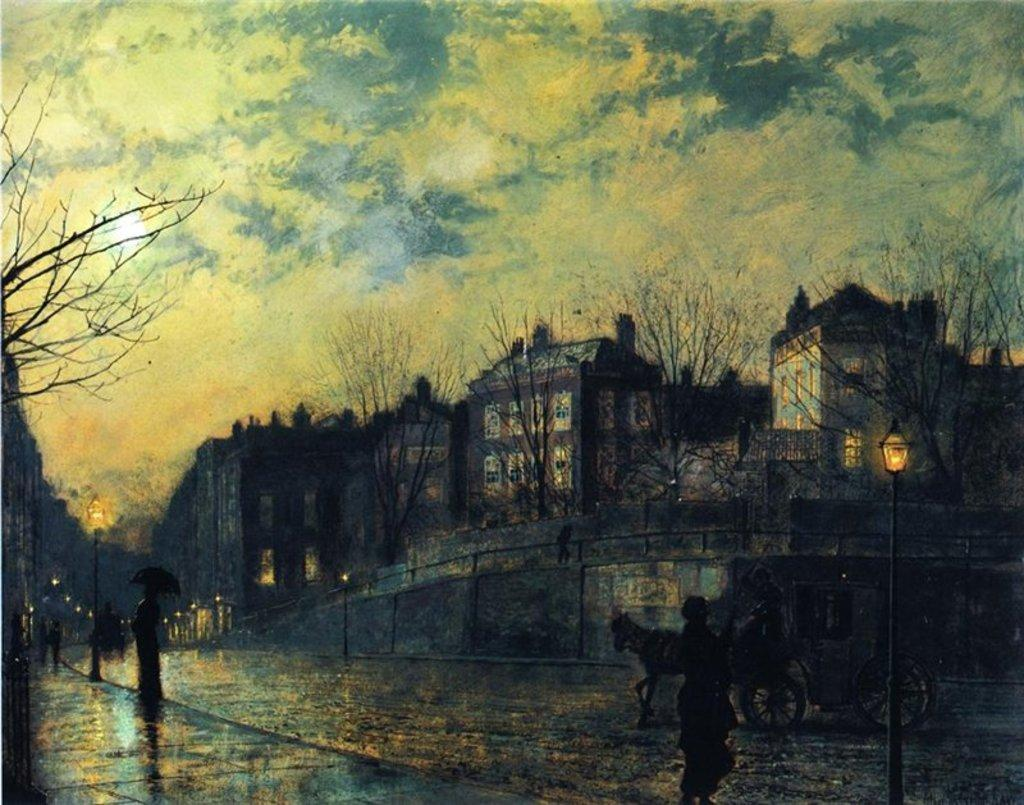What is depicted in the art in the image? There is an art of a building in the image. Can you describe the people in the image? There are people in the image. What is being used to transport something in the image? There is a cart with an animal in the image. What are the poles with lights used for in the image? The poles with lights are used for illumination in the image. What type of vegetation is present in the image? Dry trees are present in the image. What is visible in the background of the image? The sky is visible in the image, and clouds are visible in the sky. What type of popcorn is being served during the learning session in the image? There is no popcorn or learning session present in the image. What day of the week is it in the image? The day of the week is not mentioned or visible in the image. 